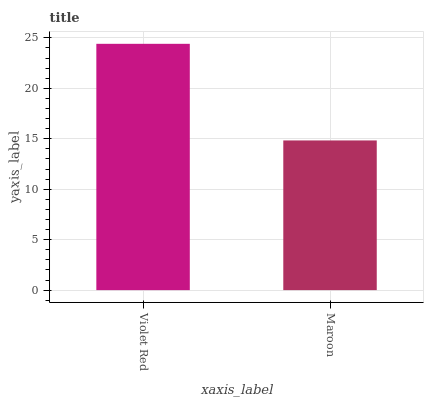Is Maroon the minimum?
Answer yes or no. Yes. Is Violet Red the maximum?
Answer yes or no. Yes. Is Maroon the maximum?
Answer yes or no. No. Is Violet Red greater than Maroon?
Answer yes or no. Yes. Is Maroon less than Violet Red?
Answer yes or no. Yes. Is Maroon greater than Violet Red?
Answer yes or no. No. Is Violet Red less than Maroon?
Answer yes or no. No. Is Violet Red the high median?
Answer yes or no. Yes. Is Maroon the low median?
Answer yes or no. Yes. Is Maroon the high median?
Answer yes or no. No. Is Violet Red the low median?
Answer yes or no. No. 